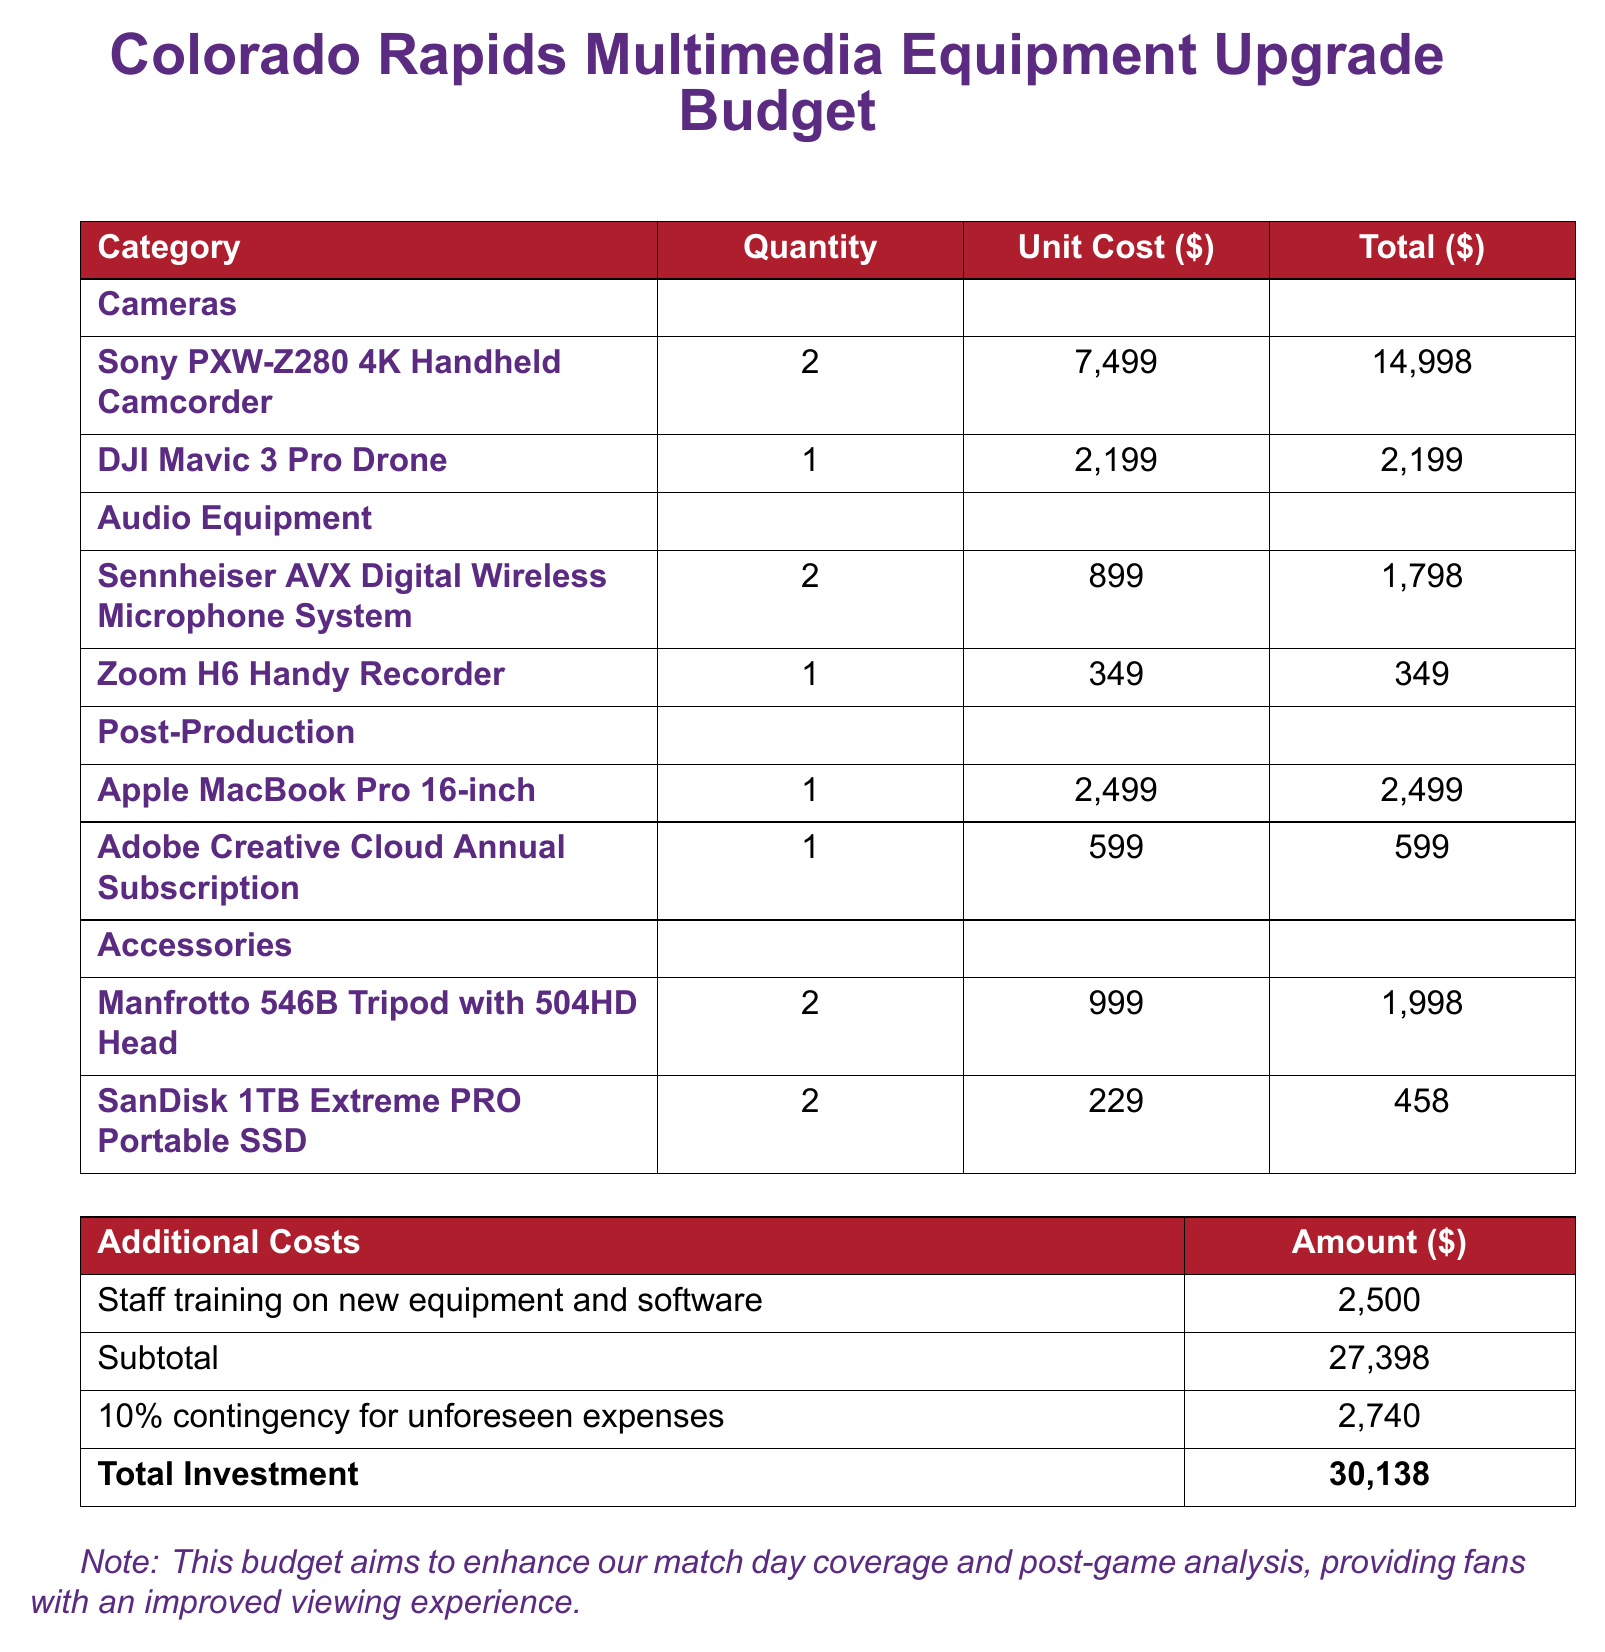What is the total investment amount? The total investment amount is indicated at the bottom of the budget document as the final figure after adding up expenses and contingency.
Answer: 30,138 How many Sony PXW-Z280 cameras are included? The document lists the quantity of Sony PXW-Z280 cameras under the cameras section.
Answer: 2 What is the unit cost of the DJI Mavic 3 Pro Drone? The document provides the individual price for the DJI Mavic 3 Pro Drone under the cameras category.
Answer: 2,199 What is the amount allocated for staff training? Staff training costs are listed as an additional cost in the budget document.
Answer: 2,500 What is the total cost for audio equipment? To find this, one must sum the costs for both the microphone system and the recorder in the audio equipment section.
Answer: 2,147 What is the contingency percentage applied in the budget? The document states that a contingency amount is added, which is calculated as a percentage of the subtotal.
Answer: 10% How many tripods are included in the accessories section? The accessories section specifically states the quantity of tripods included in the budget.
Answer: 2 What is the cost of the Adobe Creative Cloud annual subscription? The document mentions the cost for the Adobe Creative Cloud subscription under post-production expenses.
Answer: 599 What equipment is used for post-production? The post-production category lists specific equipment required, including a MacBook Pro and Adobe software.
Answer: Apple MacBook Pro 16-inch, Adobe Creative Cloud Annual Subscription 